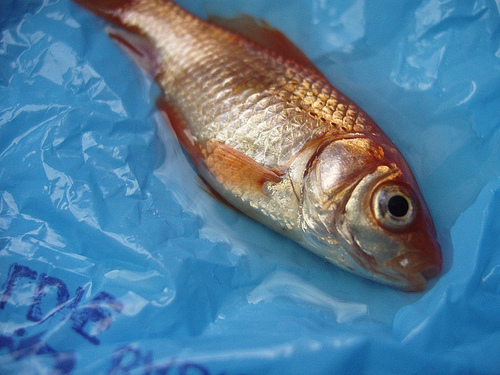<image>
Is there a tail next to the letter d? No. The tail is not positioned next to the letter d. They are located in different areas of the scene. 